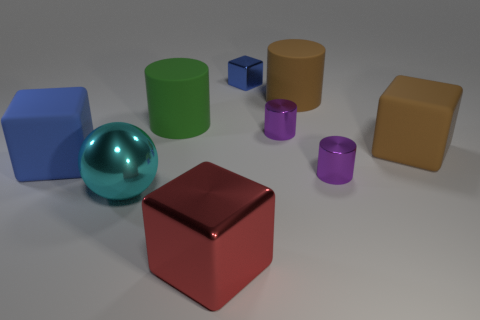What number of large things are both on the right side of the large red metallic thing and to the left of the big green object?
Make the answer very short. 0. The matte cylinder that is to the right of the blue cube behind the large brown cylinder is what color?
Offer a terse response. Brown. Are there an equal number of large red metallic cubes behind the cyan ball and small yellow cylinders?
Offer a very short reply. Yes. There is a blue cube that is to the left of the metallic block to the right of the large metal block; how many big brown rubber blocks are to the left of it?
Your answer should be very brief. 0. There is a large metallic object that is to the left of the red metal object; what is its color?
Make the answer very short. Cyan. What is the large block that is right of the green object and behind the large metallic ball made of?
Offer a terse response. Rubber. What number of metallic things are left of the big cube that is in front of the big blue rubber object?
Keep it short and to the point. 1. The small blue metallic object has what shape?
Your answer should be compact. Cube. What shape is the blue thing that is the same material as the green object?
Offer a terse response. Cube. There is a small purple metal object in front of the large blue cube; is it the same shape as the big green matte thing?
Provide a succinct answer. Yes. 